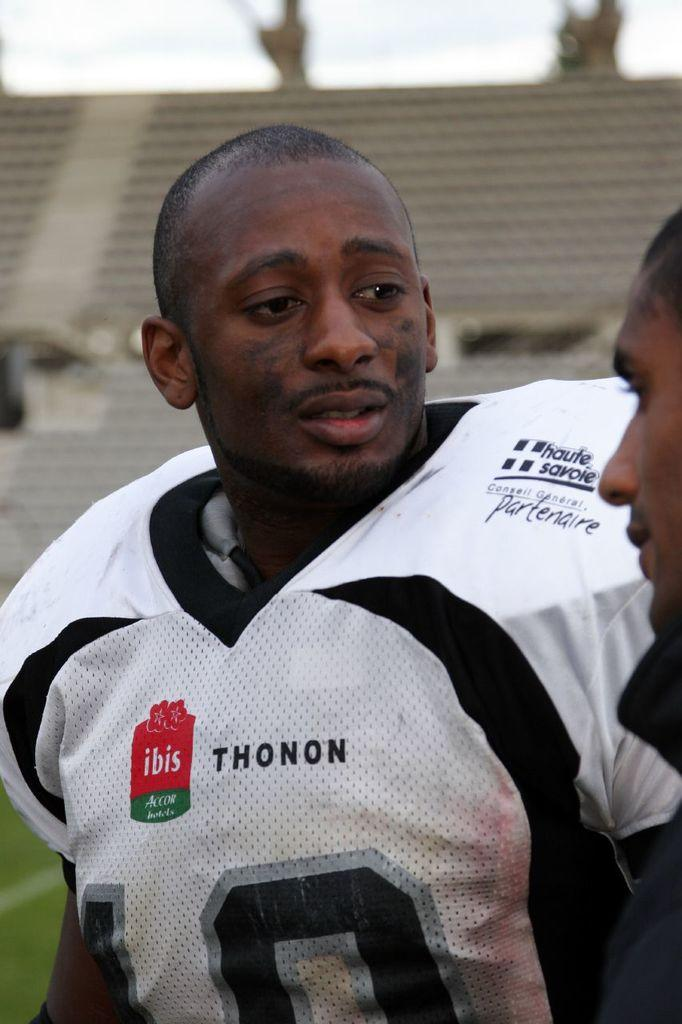<image>
Give a short and clear explanation of the subsequent image. An ad for Ibis Accor hotels is on a football player's jersey. 